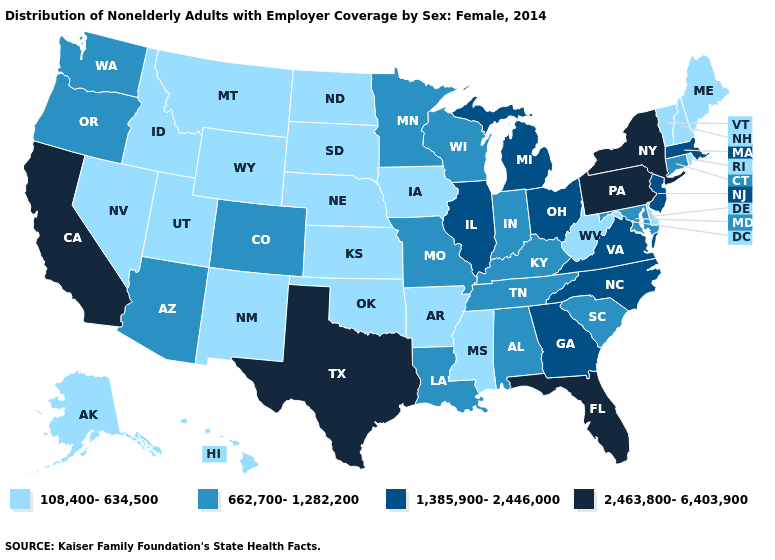Does Wyoming have a lower value than Virginia?
Short answer required. Yes. What is the value of Missouri?
Concise answer only. 662,700-1,282,200. Name the states that have a value in the range 108,400-634,500?
Concise answer only. Alaska, Arkansas, Delaware, Hawaii, Idaho, Iowa, Kansas, Maine, Mississippi, Montana, Nebraska, Nevada, New Hampshire, New Mexico, North Dakota, Oklahoma, Rhode Island, South Dakota, Utah, Vermont, West Virginia, Wyoming. Does Wisconsin have the highest value in the USA?
Keep it brief. No. What is the value of Maryland?
Quick response, please. 662,700-1,282,200. What is the lowest value in the USA?
Write a very short answer. 108,400-634,500. What is the value of Michigan?
Quick response, please. 1,385,900-2,446,000. What is the value of West Virginia?
Short answer required. 108,400-634,500. Does Florida have the highest value in the South?
Write a very short answer. Yes. What is the value of Kansas?
Be succinct. 108,400-634,500. Name the states that have a value in the range 2,463,800-6,403,900?
Write a very short answer. California, Florida, New York, Pennsylvania, Texas. Name the states that have a value in the range 2,463,800-6,403,900?
Give a very brief answer. California, Florida, New York, Pennsylvania, Texas. Does Tennessee have the lowest value in the South?
Short answer required. No. Does the map have missing data?
Write a very short answer. No. 